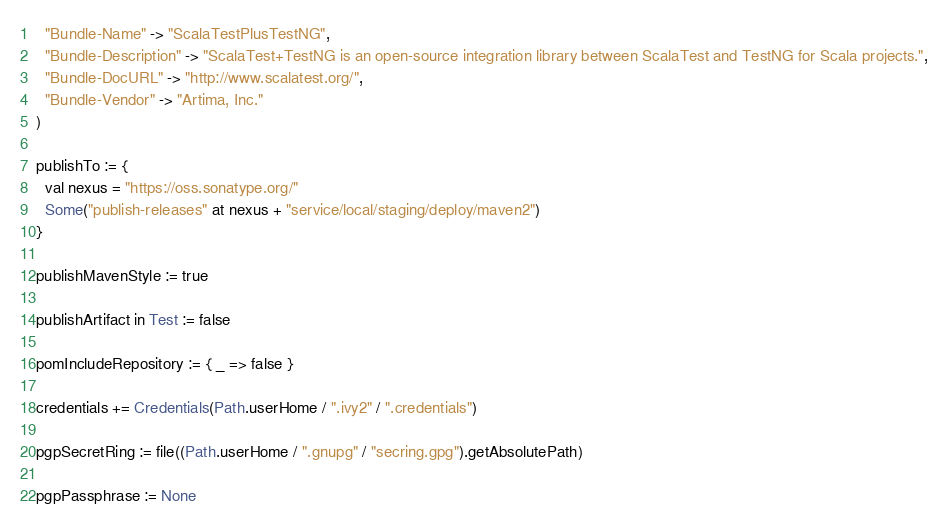Convert code to text. <code><loc_0><loc_0><loc_500><loc_500><_Scala_>  "Bundle-Name" -> "ScalaTestPlusTestNG",
  "Bundle-Description" -> "ScalaTest+TestNG is an open-source integration library between ScalaTest and TestNG for Scala projects.",
  "Bundle-DocURL" -> "http://www.scalatest.org/",
  "Bundle-Vendor" -> "Artima, Inc."
)

publishTo := {
  val nexus = "https://oss.sonatype.org/"
  Some("publish-releases" at nexus + "service/local/staging/deploy/maven2")
}

publishMavenStyle := true

publishArtifact in Test := false

pomIncludeRepository := { _ => false }

credentials += Credentials(Path.userHome / ".ivy2" / ".credentials")

pgpSecretRing := file((Path.userHome / ".gnupg" / "secring.gpg").getAbsolutePath)

pgpPassphrase := None
</code> 